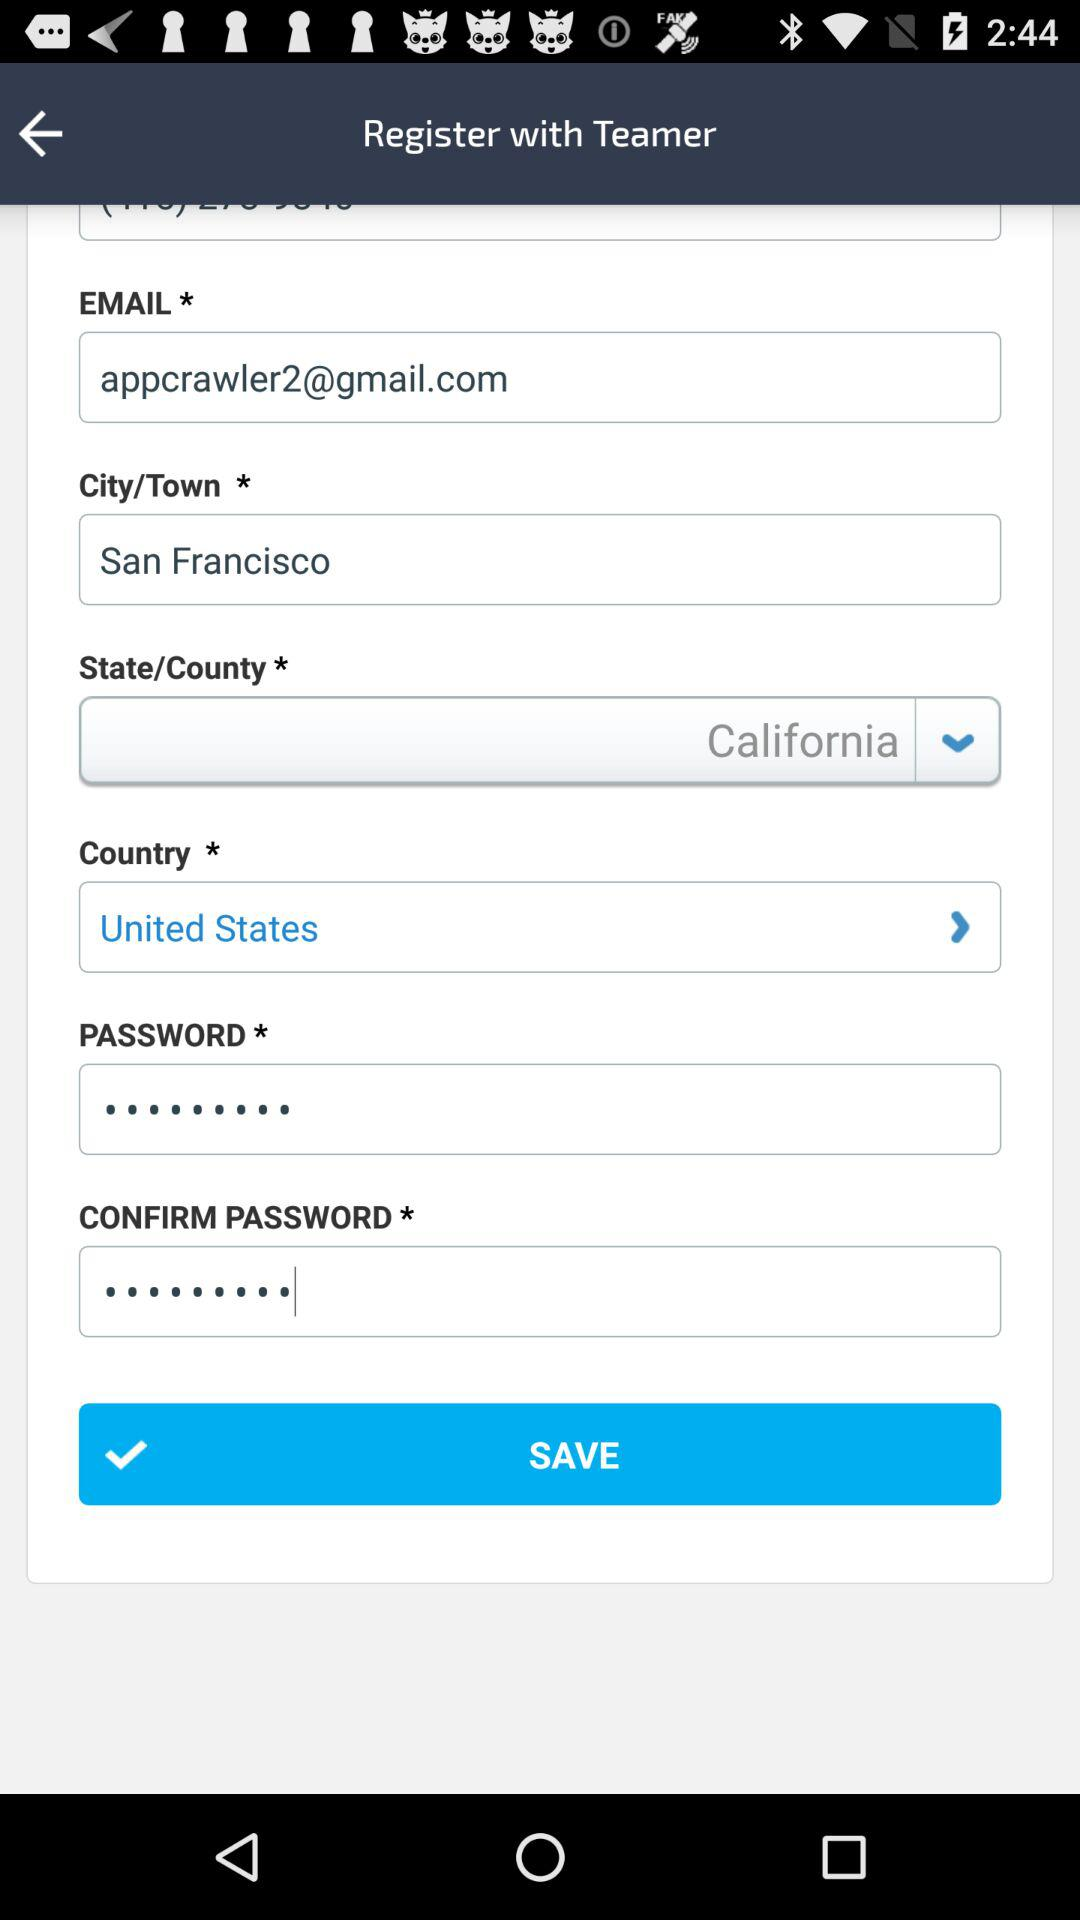What's the Google mail address used to register with the Teamer Application? The Google mail address used to register with the Teamer Application is appcrawler2@gmail.com. 